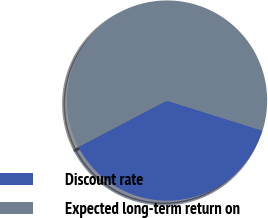Convert chart to OTSL. <chart><loc_0><loc_0><loc_500><loc_500><pie_chart><fcel>Discount rate<fcel>Expected long-term return on<nl><fcel>37.45%<fcel>62.55%<nl></chart> 